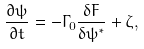<formula> <loc_0><loc_0><loc_500><loc_500>\frac { \partial \psi } { \partial t } = - \Gamma _ { 0 } \frac { \delta F } { \delta \psi ^ { * } } + \zeta ,</formula> 